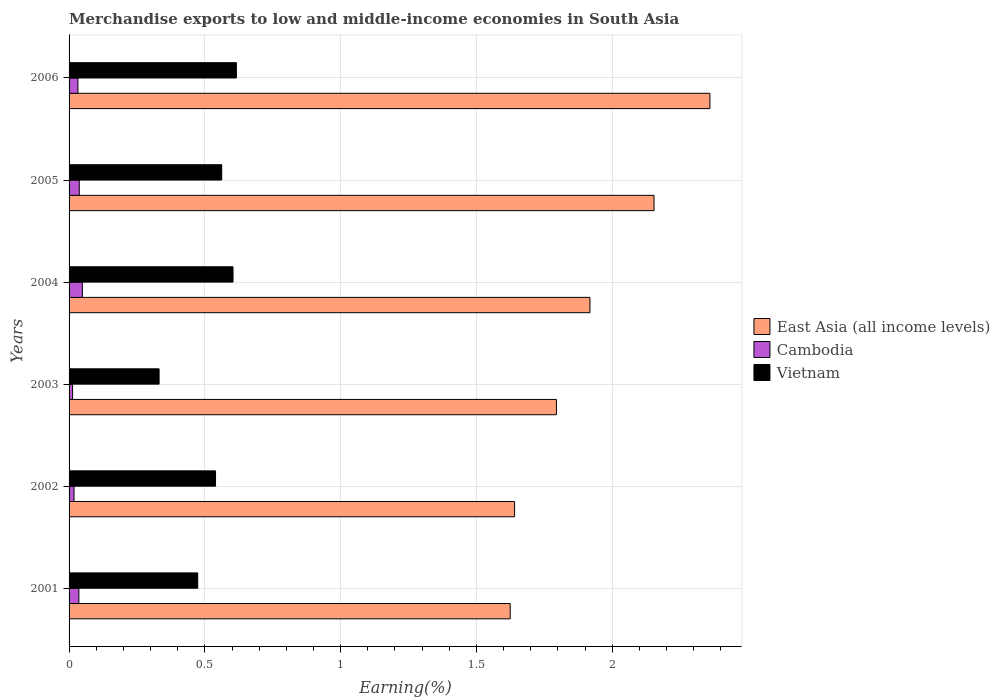How many different coloured bars are there?
Ensure brevity in your answer.  3. How many groups of bars are there?
Provide a succinct answer. 6. Are the number of bars per tick equal to the number of legend labels?
Ensure brevity in your answer.  Yes. How many bars are there on the 1st tick from the top?
Provide a short and direct response. 3. How many bars are there on the 1st tick from the bottom?
Offer a terse response. 3. In how many cases, is the number of bars for a given year not equal to the number of legend labels?
Provide a succinct answer. 0. What is the percentage of amount earned from merchandise exports in Vietnam in 2005?
Keep it short and to the point. 0.56. Across all years, what is the maximum percentage of amount earned from merchandise exports in East Asia (all income levels)?
Provide a short and direct response. 2.36. Across all years, what is the minimum percentage of amount earned from merchandise exports in East Asia (all income levels)?
Your answer should be very brief. 1.62. In which year was the percentage of amount earned from merchandise exports in Cambodia maximum?
Keep it short and to the point. 2004. In which year was the percentage of amount earned from merchandise exports in Vietnam minimum?
Provide a short and direct response. 2003. What is the total percentage of amount earned from merchandise exports in East Asia (all income levels) in the graph?
Your answer should be compact. 11.49. What is the difference between the percentage of amount earned from merchandise exports in Cambodia in 2001 and that in 2002?
Provide a succinct answer. 0.02. What is the difference between the percentage of amount earned from merchandise exports in Cambodia in 2001 and the percentage of amount earned from merchandise exports in East Asia (all income levels) in 2002?
Your response must be concise. -1.6. What is the average percentage of amount earned from merchandise exports in Vietnam per year?
Provide a succinct answer. 0.52. In the year 2002, what is the difference between the percentage of amount earned from merchandise exports in Vietnam and percentage of amount earned from merchandise exports in East Asia (all income levels)?
Provide a short and direct response. -1.1. What is the ratio of the percentage of amount earned from merchandise exports in Vietnam in 2002 to that in 2003?
Your answer should be very brief. 1.63. What is the difference between the highest and the second highest percentage of amount earned from merchandise exports in East Asia (all income levels)?
Make the answer very short. 0.21. What is the difference between the highest and the lowest percentage of amount earned from merchandise exports in Cambodia?
Ensure brevity in your answer.  0.04. What does the 3rd bar from the top in 2002 represents?
Offer a very short reply. East Asia (all income levels). What does the 1st bar from the bottom in 2002 represents?
Give a very brief answer. East Asia (all income levels). How many years are there in the graph?
Provide a short and direct response. 6. What is the difference between two consecutive major ticks on the X-axis?
Your answer should be compact. 0.5. Where does the legend appear in the graph?
Your response must be concise. Center right. How many legend labels are there?
Make the answer very short. 3. What is the title of the graph?
Provide a succinct answer. Merchandise exports to low and middle-income economies in South Asia. What is the label or title of the X-axis?
Make the answer very short. Earning(%). What is the Earning(%) in East Asia (all income levels) in 2001?
Offer a terse response. 1.62. What is the Earning(%) in Cambodia in 2001?
Your answer should be compact. 0.04. What is the Earning(%) in Vietnam in 2001?
Your response must be concise. 0.47. What is the Earning(%) of East Asia (all income levels) in 2002?
Provide a succinct answer. 1.64. What is the Earning(%) of Cambodia in 2002?
Make the answer very short. 0.02. What is the Earning(%) in Vietnam in 2002?
Provide a short and direct response. 0.54. What is the Earning(%) in East Asia (all income levels) in 2003?
Keep it short and to the point. 1.79. What is the Earning(%) in Cambodia in 2003?
Your answer should be compact. 0.01. What is the Earning(%) in Vietnam in 2003?
Give a very brief answer. 0.33. What is the Earning(%) in East Asia (all income levels) in 2004?
Your response must be concise. 1.92. What is the Earning(%) in Cambodia in 2004?
Give a very brief answer. 0.05. What is the Earning(%) of Vietnam in 2004?
Offer a terse response. 0.6. What is the Earning(%) of East Asia (all income levels) in 2005?
Offer a very short reply. 2.15. What is the Earning(%) of Cambodia in 2005?
Your response must be concise. 0.04. What is the Earning(%) in Vietnam in 2005?
Give a very brief answer. 0.56. What is the Earning(%) in East Asia (all income levels) in 2006?
Your response must be concise. 2.36. What is the Earning(%) of Cambodia in 2006?
Give a very brief answer. 0.03. What is the Earning(%) of Vietnam in 2006?
Provide a succinct answer. 0.62. Across all years, what is the maximum Earning(%) in East Asia (all income levels)?
Offer a very short reply. 2.36. Across all years, what is the maximum Earning(%) of Cambodia?
Provide a succinct answer. 0.05. Across all years, what is the maximum Earning(%) of Vietnam?
Your response must be concise. 0.62. Across all years, what is the minimum Earning(%) in East Asia (all income levels)?
Provide a succinct answer. 1.62. Across all years, what is the minimum Earning(%) of Cambodia?
Your response must be concise. 0.01. Across all years, what is the minimum Earning(%) in Vietnam?
Make the answer very short. 0.33. What is the total Earning(%) in East Asia (all income levels) in the graph?
Offer a terse response. 11.49. What is the total Earning(%) of Cambodia in the graph?
Your response must be concise. 0.19. What is the total Earning(%) of Vietnam in the graph?
Offer a very short reply. 3.13. What is the difference between the Earning(%) of East Asia (all income levels) in 2001 and that in 2002?
Offer a terse response. -0.02. What is the difference between the Earning(%) in Cambodia in 2001 and that in 2002?
Provide a short and direct response. 0.02. What is the difference between the Earning(%) of Vietnam in 2001 and that in 2002?
Offer a terse response. -0.07. What is the difference between the Earning(%) of East Asia (all income levels) in 2001 and that in 2003?
Ensure brevity in your answer.  -0.17. What is the difference between the Earning(%) of Cambodia in 2001 and that in 2003?
Keep it short and to the point. 0.02. What is the difference between the Earning(%) of Vietnam in 2001 and that in 2003?
Your answer should be compact. 0.14. What is the difference between the Earning(%) in East Asia (all income levels) in 2001 and that in 2004?
Ensure brevity in your answer.  -0.29. What is the difference between the Earning(%) in Cambodia in 2001 and that in 2004?
Your answer should be very brief. -0.01. What is the difference between the Earning(%) in Vietnam in 2001 and that in 2004?
Provide a succinct answer. -0.13. What is the difference between the Earning(%) of East Asia (all income levels) in 2001 and that in 2005?
Your answer should be very brief. -0.53. What is the difference between the Earning(%) of Cambodia in 2001 and that in 2005?
Provide a succinct answer. -0. What is the difference between the Earning(%) of Vietnam in 2001 and that in 2005?
Your answer should be very brief. -0.09. What is the difference between the Earning(%) in East Asia (all income levels) in 2001 and that in 2006?
Ensure brevity in your answer.  -0.74. What is the difference between the Earning(%) in Cambodia in 2001 and that in 2006?
Offer a very short reply. 0. What is the difference between the Earning(%) of Vietnam in 2001 and that in 2006?
Provide a succinct answer. -0.14. What is the difference between the Earning(%) of East Asia (all income levels) in 2002 and that in 2003?
Ensure brevity in your answer.  -0.15. What is the difference between the Earning(%) in Cambodia in 2002 and that in 2003?
Make the answer very short. 0.01. What is the difference between the Earning(%) of Vietnam in 2002 and that in 2003?
Provide a succinct answer. 0.21. What is the difference between the Earning(%) in East Asia (all income levels) in 2002 and that in 2004?
Provide a succinct answer. -0.28. What is the difference between the Earning(%) of Cambodia in 2002 and that in 2004?
Give a very brief answer. -0.03. What is the difference between the Earning(%) of Vietnam in 2002 and that in 2004?
Give a very brief answer. -0.06. What is the difference between the Earning(%) in East Asia (all income levels) in 2002 and that in 2005?
Ensure brevity in your answer.  -0.51. What is the difference between the Earning(%) of Cambodia in 2002 and that in 2005?
Your answer should be compact. -0.02. What is the difference between the Earning(%) in Vietnam in 2002 and that in 2005?
Your answer should be compact. -0.02. What is the difference between the Earning(%) in East Asia (all income levels) in 2002 and that in 2006?
Ensure brevity in your answer.  -0.72. What is the difference between the Earning(%) of Cambodia in 2002 and that in 2006?
Offer a terse response. -0.01. What is the difference between the Earning(%) in Vietnam in 2002 and that in 2006?
Offer a very short reply. -0.08. What is the difference between the Earning(%) in East Asia (all income levels) in 2003 and that in 2004?
Make the answer very short. -0.12. What is the difference between the Earning(%) of Cambodia in 2003 and that in 2004?
Offer a very short reply. -0.04. What is the difference between the Earning(%) in Vietnam in 2003 and that in 2004?
Provide a short and direct response. -0.27. What is the difference between the Earning(%) in East Asia (all income levels) in 2003 and that in 2005?
Your answer should be compact. -0.36. What is the difference between the Earning(%) of Cambodia in 2003 and that in 2005?
Make the answer very short. -0.02. What is the difference between the Earning(%) of Vietnam in 2003 and that in 2005?
Provide a short and direct response. -0.23. What is the difference between the Earning(%) of East Asia (all income levels) in 2003 and that in 2006?
Your answer should be very brief. -0.57. What is the difference between the Earning(%) in Cambodia in 2003 and that in 2006?
Ensure brevity in your answer.  -0.02. What is the difference between the Earning(%) in Vietnam in 2003 and that in 2006?
Keep it short and to the point. -0.28. What is the difference between the Earning(%) in East Asia (all income levels) in 2004 and that in 2005?
Your answer should be compact. -0.24. What is the difference between the Earning(%) in Cambodia in 2004 and that in 2005?
Your response must be concise. 0.01. What is the difference between the Earning(%) in Vietnam in 2004 and that in 2005?
Make the answer very short. 0.04. What is the difference between the Earning(%) in East Asia (all income levels) in 2004 and that in 2006?
Your answer should be very brief. -0.44. What is the difference between the Earning(%) of Cambodia in 2004 and that in 2006?
Offer a very short reply. 0.02. What is the difference between the Earning(%) of Vietnam in 2004 and that in 2006?
Make the answer very short. -0.01. What is the difference between the Earning(%) of East Asia (all income levels) in 2005 and that in 2006?
Your answer should be very brief. -0.21. What is the difference between the Earning(%) in Cambodia in 2005 and that in 2006?
Your response must be concise. 0. What is the difference between the Earning(%) in Vietnam in 2005 and that in 2006?
Give a very brief answer. -0.05. What is the difference between the Earning(%) of East Asia (all income levels) in 2001 and the Earning(%) of Cambodia in 2002?
Offer a terse response. 1.61. What is the difference between the Earning(%) of East Asia (all income levels) in 2001 and the Earning(%) of Vietnam in 2002?
Your answer should be compact. 1.09. What is the difference between the Earning(%) of Cambodia in 2001 and the Earning(%) of Vietnam in 2002?
Offer a terse response. -0.5. What is the difference between the Earning(%) in East Asia (all income levels) in 2001 and the Earning(%) in Cambodia in 2003?
Provide a succinct answer. 1.61. What is the difference between the Earning(%) of East Asia (all income levels) in 2001 and the Earning(%) of Vietnam in 2003?
Keep it short and to the point. 1.29. What is the difference between the Earning(%) of Cambodia in 2001 and the Earning(%) of Vietnam in 2003?
Ensure brevity in your answer.  -0.3. What is the difference between the Earning(%) of East Asia (all income levels) in 2001 and the Earning(%) of Cambodia in 2004?
Offer a terse response. 1.58. What is the difference between the Earning(%) in East Asia (all income levels) in 2001 and the Earning(%) in Vietnam in 2004?
Ensure brevity in your answer.  1.02. What is the difference between the Earning(%) of Cambodia in 2001 and the Earning(%) of Vietnam in 2004?
Ensure brevity in your answer.  -0.57. What is the difference between the Earning(%) of East Asia (all income levels) in 2001 and the Earning(%) of Cambodia in 2005?
Your answer should be very brief. 1.59. What is the difference between the Earning(%) in East Asia (all income levels) in 2001 and the Earning(%) in Vietnam in 2005?
Your answer should be very brief. 1.06. What is the difference between the Earning(%) of Cambodia in 2001 and the Earning(%) of Vietnam in 2005?
Your response must be concise. -0.53. What is the difference between the Earning(%) in East Asia (all income levels) in 2001 and the Earning(%) in Cambodia in 2006?
Offer a terse response. 1.59. What is the difference between the Earning(%) of East Asia (all income levels) in 2001 and the Earning(%) of Vietnam in 2006?
Make the answer very short. 1.01. What is the difference between the Earning(%) in Cambodia in 2001 and the Earning(%) in Vietnam in 2006?
Make the answer very short. -0.58. What is the difference between the Earning(%) in East Asia (all income levels) in 2002 and the Earning(%) in Cambodia in 2003?
Offer a terse response. 1.63. What is the difference between the Earning(%) of East Asia (all income levels) in 2002 and the Earning(%) of Vietnam in 2003?
Make the answer very short. 1.31. What is the difference between the Earning(%) in Cambodia in 2002 and the Earning(%) in Vietnam in 2003?
Offer a very short reply. -0.31. What is the difference between the Earning(%) in East Asia (all income levels) in 2002 and the Earning(%) in Cambodia in 2004?
Your response must be concise. 1.59. What is the difference between the Earning(%) in East Asia (all income levels) in 2002 and the Earning(%) in Vietnam in 2004?
Keep it short and to the point. 1.04. What is the difference between the Earning(%) of Cambodia in 2002 and the Earning(%) of Vietnam in 2004?
Your response must be concise. -0.59. What is the difference between the Earning(%) in East Asia (all income levels) in 2002 and the Earning(%) in Cambodia in 2005?
Make the answer very short. 1.6. What is the difference between the Earning(%) of East Asia (all income levels) in 2002 and the Earning(%) of Vietnam in 2005?
Give a very brief answer. 1.08. What is the difference between the Earning(%) in Cambodia in 2002 and the Earning(%) in Vietnam in 2005?
Provide a succinct answer. -0.54. What is the difference between the Earning(%) of East Asia (all income levels) in 2002 and the Earning(%) of Cambodia in 2006?
Offer a very short reply. 1.61. What is the difference between the Earning(%) in East Asia (all income levels) in 2002 and the Earning(%) in Vietnam in 2006?
Make the answer very short. 1.02. What is the difference between the Earning(%) of Cambodia in 2002 and the Earning(%) of Vietnam in 2006?
Ensure brevity in your answer.  -0.6. What is the difference between the Earning(%) of East Asia (all income levels) in 2003 and the Earning(%) of Cambodia in 2004?
Your response must be concise. 1.75. What is the difference between the Earning(%) in East Asia (all income levels) in 2003 and the Earning(%) in Vietnam in 2004?
Your answer should be compact. 1.19. What is the difference between the Earning(%) in Cambodia in 2003 and the Earning(%) in Vietnam in 2004?
Your response must be concise. -0.59. What is the difference between the Earning(%) of East Asia (all income levels) in 2003 and the Earning(%) of Cambodia in 2005?
Provide a short and direct response. 1.76. What is the difference between the Earning(%) of East Asia (all income levels) in 2003 and the Earning(%) of Vietnam in 2005?
Provide a succinct answer. 1.23. What is the difference between the Earning(%) in Cambodia in 2003 and the Earning(%) in Vietnam in 2005?
Your answer should be compact. -0.55. What is the difference between the Earning(%) of East Asia (all income levels) in 2003 and the Earning(%) of Cambodia in 2006?
Make the answer very short. 1.76. What is the difference between the Earning(%) in East Asia (all income levels) in 2003 and the Earning(%) in Vietnam in 2006?
Offer a very short reply. 1.18. What is the difference between the Earning(%) of Cambodia in 2003 and the Earning(%) of Vietnam in 2006?
Keep it short and to the point. -0.6. What is the difference between the Earning(%) of East Asia (all income levels) in 2004 and the Earning(%) of Cambodia in 2005?
Offer a terse response. 1.88. What is the difference between the Earning(%) of East Asia (all income levels) in 2004 and the Earning(%) of Vietnam in 2005?
Give a very brief answer. 1.36. What is the difference between the Earning(%) in Cambodia in 2004 and the Earning(%) in Vietnam in 2005?
Offer a very short reply. -0.51. What is the difference between the Earning(%) in East Asia (all income levels) in 2004 and the Earning(%) in Cambodia in 2006?
Ensure brevity in your answer.  1.89. What is the difference between the Earning(%) of East Asia (all income levels) in 2004 and the Earning(%) of Vietnam in 2006?
Make the answer very short. 1.3. What is the difference between the Earning(%) in Cambodia in 2004 and the Earning(%) in Vietnam in 2006?
Ensure brevity in your answer.  -0.57. What is the difference between the Earning(%) of East Asia (all income levels) in 2005 and the Earning(%) of Cambodia in 2006?
Offer a terse response. 2.12. What is the difference between the Earning(%) in East Asia (all income levels) in 2005 and the Earning(%) in Vietnam in 2006?
Your response must be concise. 1.54. What is the difference between the Earning(%) in Cambodia in 2005 and the Earning(%) in Vietnam in 2006?
Keep it short and to the point. -0.58. What is the average Earning(%) in East Asia (all income levels) per year?
Offer a very short reply. 1.92. What is the average Earning(%) in Cambodia per year?
Keep it short and to the point. 0.03. What is the average Earning(%) of Vietnam per year?
Provide a succinct answer. 0.52. In the year 2001, what is the difference between the Earning(%) in East Asia (all income levels) and Earning(%) in Cambodia?
Ensure brevity in your answer.  1.59. In the year 2001, what is the difference between the Earning(%) in East Asia (all income levels) and Earning(%) in Vietnam?
Ensure brevity in your answer.  1.15. In the year 2001, what is the difference between the Earning(%) in Cambodia and Earning(%) in Vietnam?
Your answer should be very brief. -0.44. In the year 2002, what is the difference between the Earning(%) of East Asia (all income levels) and Earning(%) of Cambodia?
Ensure brevity in your answer.  1.62. In the year 2002, what is the difference between the Earning(%) of East Asia (all income levels) and Earning(%) of Vietnam?
Make the answer very short. 1.1. In the year 2002, what is the difference between the Earning(%) in Cambodia and Earning(%) in Vietnam?
Offer a terse response. -0.52. In the year 2003, what is the difference between the Earning(%) of East Asia (all income levels) and Earning(%) of Cambodia?
Provide a short and direct response. 1.78. In the year 2003, what is the difference between the Earning(%) of East Asia (all income levels) and Earning(%) of Vietnam?
Your answer should be very brief. 1.46. In the year 2003, what is the difference between the Earning(%) in Cambodia and Earning(%) in Vietnam?
Your answer should be compact. -0.32. In the year 2004, what is the difference between the Earning(%) of East Asia (all income levels) and Earning(%) of Cambodia?
Make the answer very short. 1.87. In the year 2004, what is the difference between the Earning(%) in East Asia (all income levels) and Earning(%) in Vietnam?
Give a very brief answer. 1.31. In the year 2004, what is the difference between the Earning(%) of Cambodia and Earning(%) of Vietnam?
Provide a short and direct response. -0.55. In the year 2005, what is the difference between the Earning(%) in East Asia (all income levels) and Earning(%) in Cambodia?
Ensure brevity in your answer.  2.12. In the year 2005, what is the difference between the Earning(%) of East Asia (all income levels) and Earning(%) of Vietnam?
Your answer should be compact. 1.59. In the year 2005, what is the difference between the Earning(%) of Cambodia and Earning(%) of Vietnam?
Your answer should be very brief. -0.52. In the year 2006, what is the difference between the Earning(%) of East Asia (all income levels) and Earning(%) of Cambodia?
Ensure brevity in your answer.  2.33. In the year 2006, what is the difference between the Earning(%) of East Asia (all income levels) and Earning(%) of Vietnam?
Provide a short and direct response. 1.74. In the year 2006, what is the difference between the Earning(%) of Cambodia and Earning(%) of Vietnam?
Provide a short and direct response. -0.58. What is the ratio of the Earning(%) of East Asia (all income levels) in 2001 to that in 2002?
Ensure brevity in your answer.  0.99. What is the ratio of the Earning(%) in Cambodia in 2001 to that in 2002?
Keep it short and to the point. 1.98. What is the ratio of the Earning(%) in Vietnam in 2001 to that in 2002?
Offer a terse response. 0.88. What is the ratio of the Earning(%) of East Asia (all income levels) in 2001 to that in 2003?
Keep it short and to the point. 0.91. What is the ratio of the Earning(%) of Cambodia in 2001 to that in 2003?
Offer a very short reply. 2.8. What is the ratio of the Earning(%) of Vietnam in 2001 to that in 2003?
Your response must be concise. 1.43. What is the ratio of the Earning(%) in East Asia (all income levels) in 2001 to that in 2004?
Your response must be concise. 0.85. What is the ratio of the Earning(%) of Cambodia in 2001 to that in 2004?
Give a very brief answer. 0.74. What is the ratio of the Earning(%) of Vietnam in 2001 to that in 2004?
Provide a succinct answer. 0.78. What is the ratio of the Earning(%) in East Asia (all income levels) in 2001 to that in 2005?
Offer a very short reply. 0.75. What is the ratio of the Earning(%) of Cambodia in 2001 to that in 2005?
Ensure brevity in your answer.  0.96. What is the ratio of the Earning(%) of Vietnam in 2001 to that in 2005?
Give a very brief answer. 0.84. What is the ratio of the Earning(%) of East Asia (all income levels) in 2001 to that in 2006?
Your response must be concise. 0.69. What is the ratio of the Earning(%) in Cambodia in 2001 to that in 2006?
Keep it short and to the point. 1.11. What is the ratio of the Earning(%) in Vietnam in 2001 to that in 2006?
Your answer should be very brief. 0.77. What is the ratio of the Earning(%) in East Asia (all income levels) in 2002 to that in 2003?
Keep it short and to the point. 0.91. What is the ratio of the Earning(%) in Cambodia in 2002 to that in 2003?
Your response must be concise. 1.41. What is the ratio of the Earning(%) of Vietnam in 2002 to that in 2003?
Make the answer very short. 1.63. What is the ratio of the Earning(%) of East Asia (all income levels) in 2002 to that in 2004?
Provide a short and direct response. 0.86. What is the ratio of the Earning(%) in Cambodia in 2002 to that in 2004?
Keep it short and to the point. 0.37. What is the ratio of the Earning(%) of Vietnam in 2002 to that in 2004?
Give a very brief answer. 0.89. What is the ratio of the Earning(%) of East Asia (all income levels) in 2002 to that in 2005?
Keep it short and to the point. 0.76. What is the ratio of the Earning(%) of Cambodia in 2002 to that in 2005?
Make the answer very short. 0.48. What is the ratio of the Earning(%) of Vietnam in 2002 to that in 2005?
Your answer should be compact. 0.96. What is the ratio of the Earning(%) of East Asia (all income levels) in 2002 to that in 2006?
Provide a succinct answer. 0.7. What is the ratio of the Earning(%) in Cambodia in 2002 to that in 2006?
Your answer should be compact. 0.56. What is the ratio of the Earning(%) in Vietnam in 2002 to that in 2006?
Provide a short and direct response. 0.88. What is the ratio of the Earning(%) in East Asia (all income levels) in 2003 to that in 2004?
Your answer should be compact. 0.94. What is the ratio of the Earning(%) of Cambodia in 2003 to that in 2004?
Your answer should be very brief. 0.26. What is the ratio of the Earning(%) in Vietnam in 2003 to that in 2004?
Provide a succinct answer. 0.55. What is the ratio of the Earning(%) of East Asia (all income levels) in 2003 to that in 2005?
Your response must be concise. 0.83. What is the ratio of the Earning(%) in Cambodia in 2003 to that in 2005?
Offer a terse response. 0.34. What is the ratio of the Earning(%) in Vietnam in 2003 to that in 2005?
Your answer should be compact. 0.59. What is the ratio of the Earning(%) in East Asia (all income levels) in 2003 to that in 2006?
Make the answer very short. 0.76. What is the ratio of the Earning(%) in Cambodia in 2003 to that in 2006?
Your answer should be compact. 0.4. What is the ratio of the Earning(%) in Vietnam in 2003 to that in 2006?
Provide a short and direct response. 0.54. What is the ratio of the Earning(%) in East Asia (all income levels) in 2004 to that in 2005?
Ensure brevity in your answer.  0.89. What is the ratio of the Earning(%) in Cambodia in 2004 to that in 2005?
Make the answer very short. 1.31. What is the ratio of the Earning(%) in Vietnam in 2004 to that in 2005?
Provide a short and direct response. 1.07. What is the ratio of the Earning(%) of East Asia (all income levels) in 2004 to that in 2006?
Provide a short and direct response. 0.81. What is the ratio of the Earning(%) of Cambodia in 2004 to that in 2006?
Give a very brief answer. 1.5. What is the ratio of the Earning(%) in Vietnam in 2004 to that in 2006?
Your answer should be very brief. 0.98. What is the ratio of the Earning(%) in East Asia (all income levels) in 2005 to that in 2006?
Give a very brief answer. 0.91. What is the ratio of the Earning(%) of Cambodia in 2005 to that in 2006?
Your answer should be very brief. 1.15. What is the ratio of the Earning(%) in Vietnam in 2005 to that in 2006?
Provide a short and direct response. 0.91. What is the difference between the highest and the second highest Earning(%) in East Asia (all income levels)?
Provide a short and direct response. 0.21. What is the difference between the highest and the second highest Earning(%) of Cambodia?
Offer a very short reply. 0.01. What is the difference between the highest and the second highest Earning(%) of Vietnam?
Offer a terse response. 0.01. What is the difference between the highest and the lowest Earning(%) of East Asia (all income levels)?
Provide a short and direct response. 0.74. What is the difference between the highest and the lowest Earning(%) of Cambodia?
Your response must be concise. 0.04. What is the difference between the highest and the lowest Earning(%) of Vietnam?
Provide a succinct answer. 0.28. 